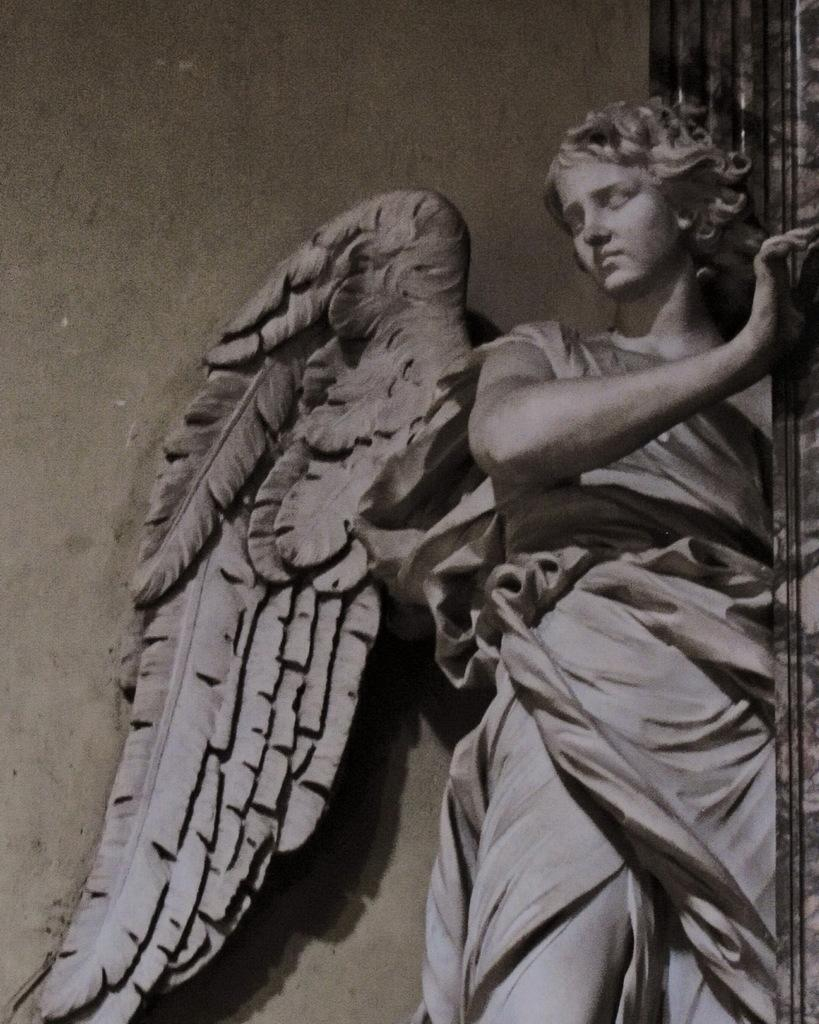What is the main subject in the image? There is a statue in the image. What can be seen in the background of the image? There is a wall in the image. Can you describe the object on the right side of the image? Unfortunately, the provided facts do not give enough information to describe the object on the right side of the image. What type of prose is being read by the statue in the image? There is no indication in the image that the statue is reading any prose, as statues are not capable of reading. 